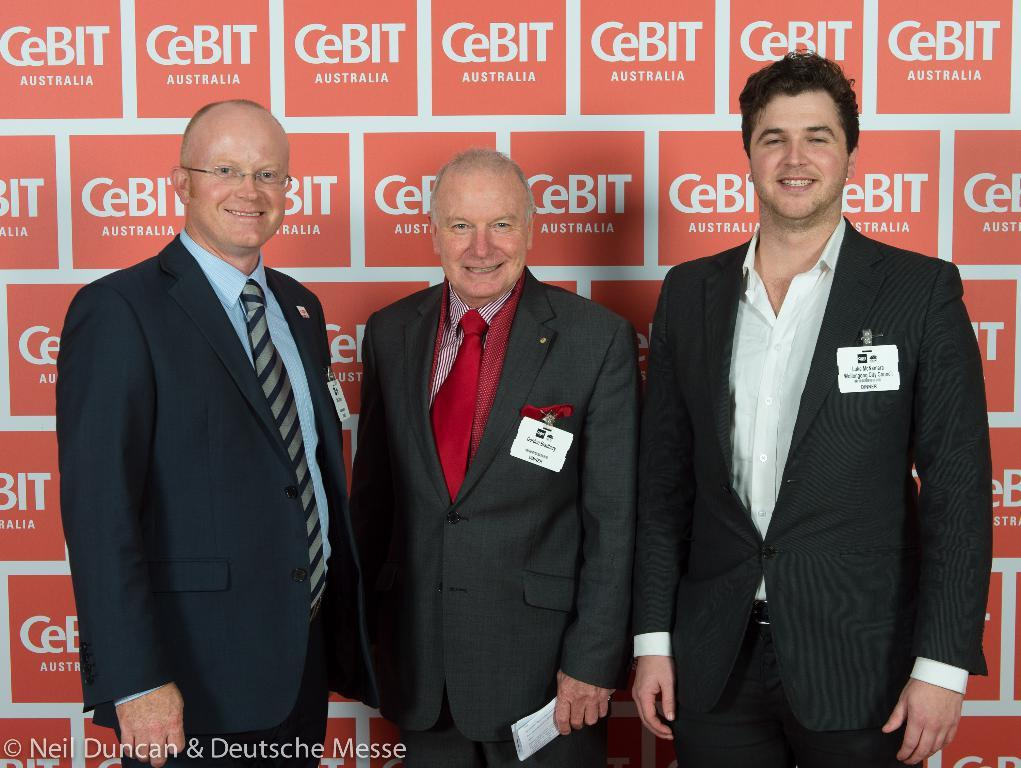How many people are in the image? There are three men in the image. What are the men doing in the image? The men are standing together and smiling. What can be seen in the background of the image? There is a wall visible in the background of the image. What type of rail can be seen connecting the tents in the image? There are no tents or rails present in the image; it features three men standing together and smiling. 